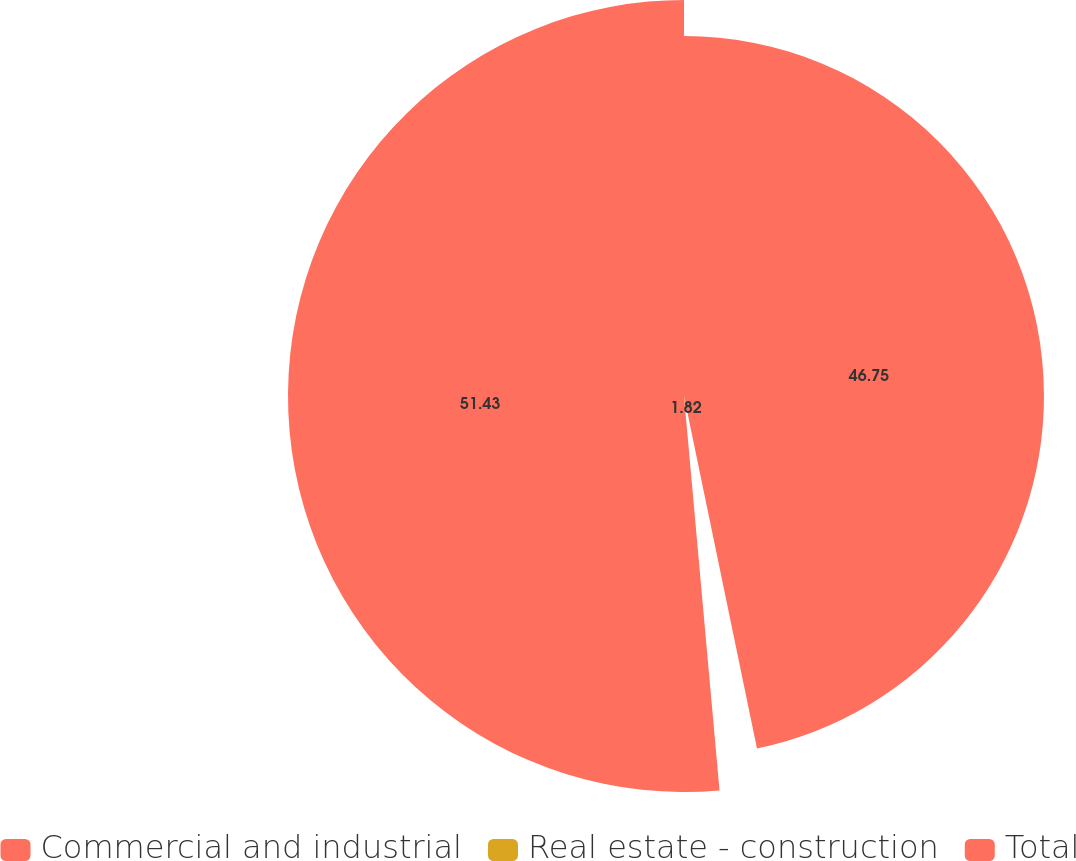Convert chart to OTSL. <chart><loc_0><loc_0><loc_500><loc_500><pie_chart><fcel>Commercial and industrial<fcel>Real estate - construction<fcel>Total<nl><fcel>46.75%<fcel>1.82%<fcel>51.43%<nl></chart> 